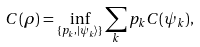<formula> <loc_0><loc_0><loc_500><loc_500>C ( \rho ) = \inf _ { \{ p _ { k } , | \psi _ { k } \rangle \} } \sum _ { k } { p _ { k } C ( \psi _ { k } ) } ,</formula> 